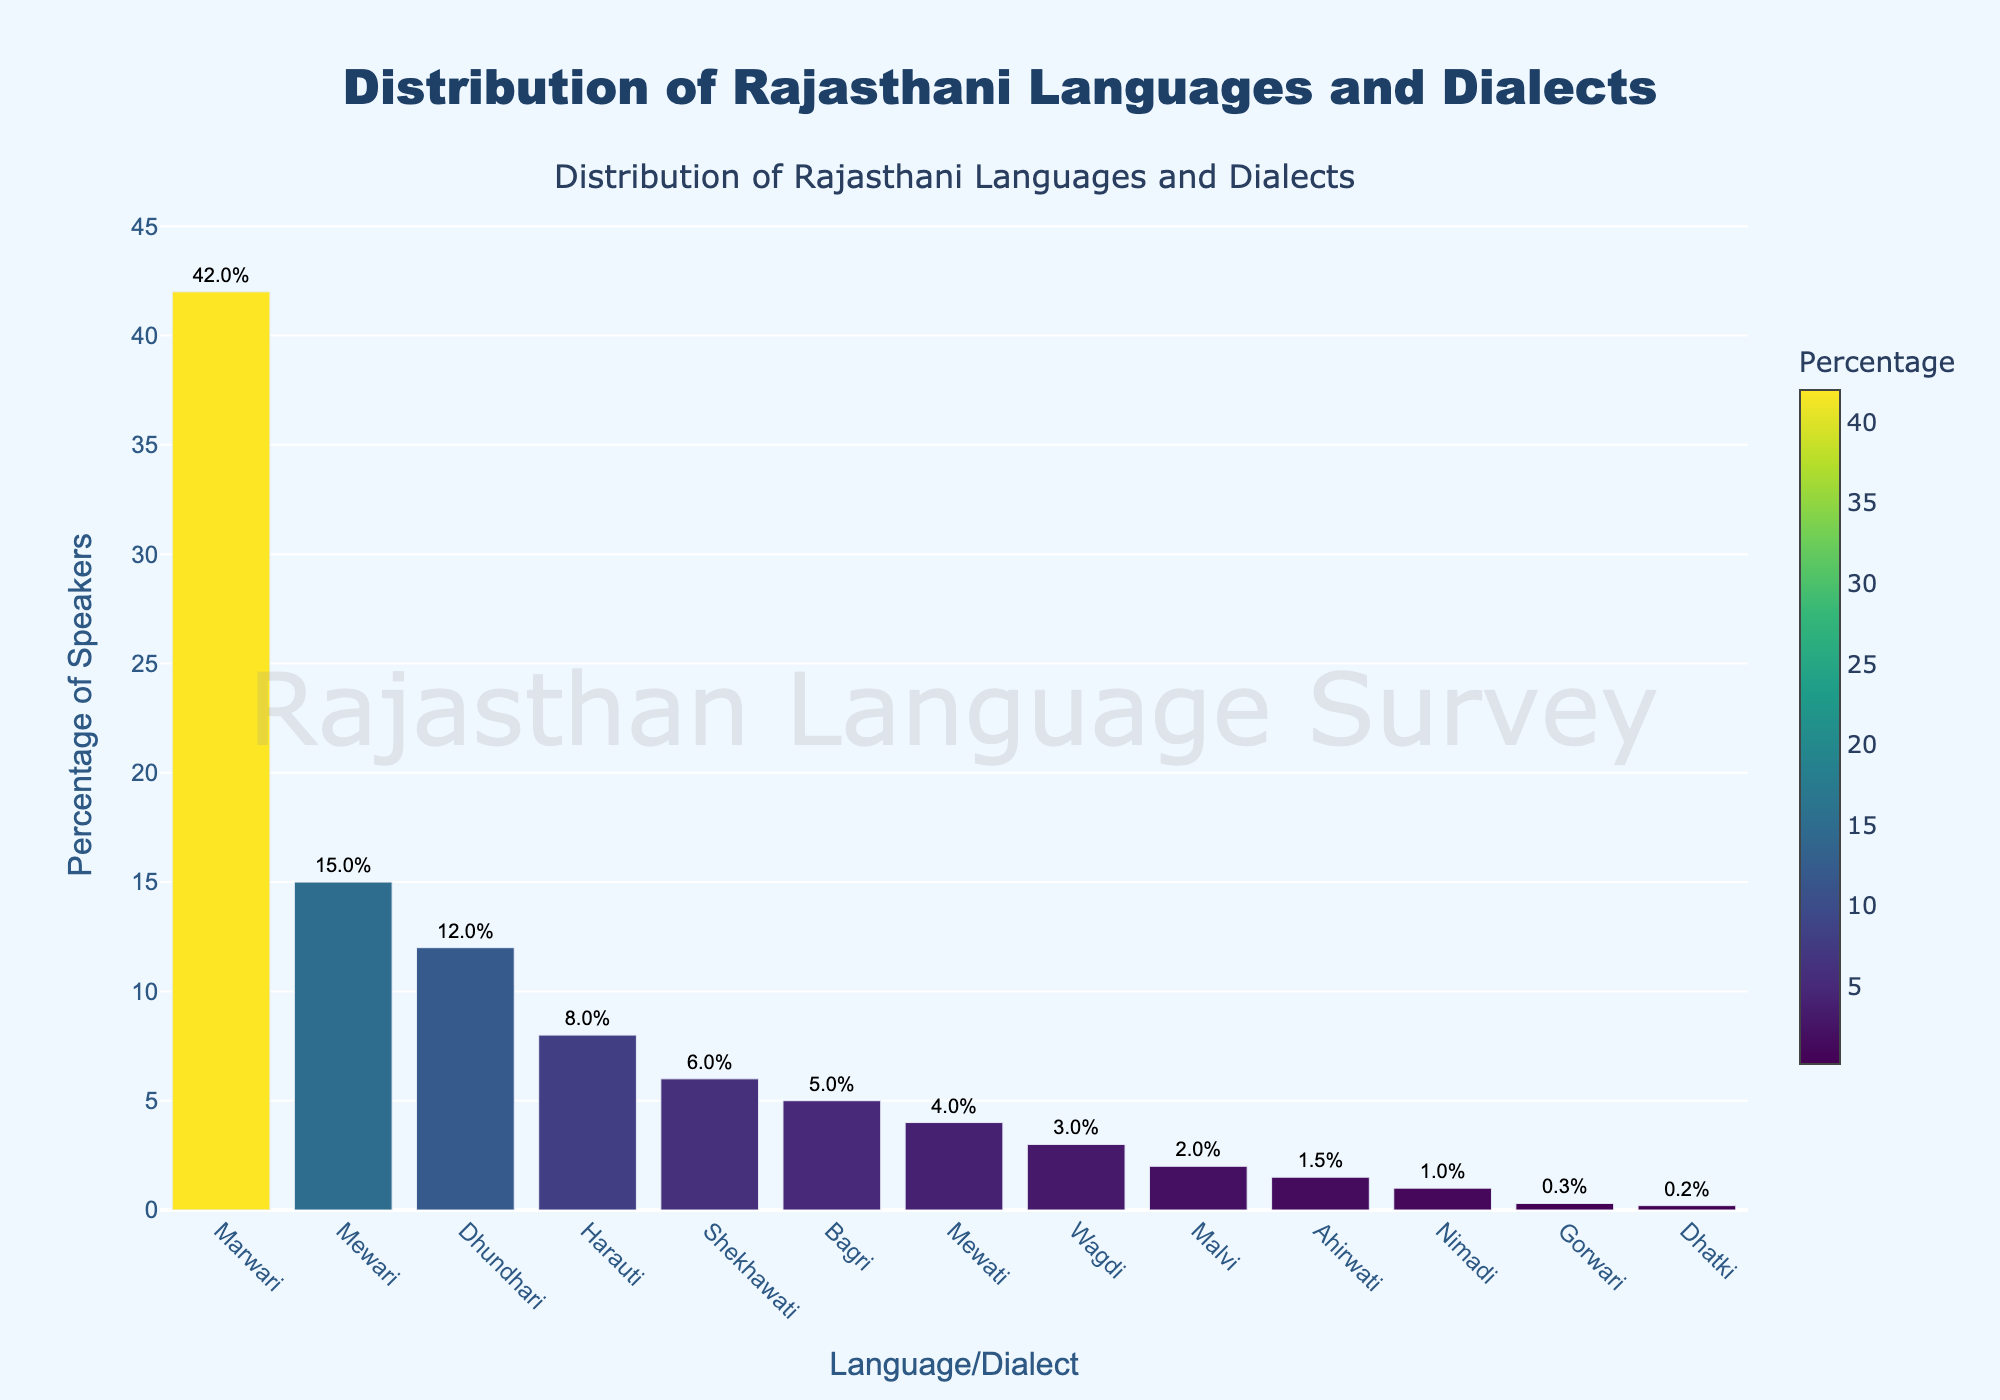What percentage of speakers does the Marwari dialect have? Look at the bar corresponding to the Marwari dialect on the x-axis and note the percentage marked at the top or displayed next to the bar.
Answer: 42% Which dialect has the smallest percentage of speakers, and what is that percentage? Identify the shortest bar on the plot, then read the label on the x-axis and the corresponding percentage.
Answer: Dhatki, 0.2% How much greater is the percentage of Marwari speakers compared to Mewari speakers? Find the percentages for both Marwari and Mewari. Subtract the percentage of Mewari from Marwari (42% - 15%).
Answer: 27% List all the dialects that have more than 10% of speakers. Identify the bars whose percentage values are above 10% and list their corresponding dialects.
Answer: Marwari, Mewari, Dhundhari What is the total percentage of speakers for Shekhawati, Bagri, and Mewati combined? Find the percentages for Shekhawati, Bagri, and Mewati. Add them together (6% + 5% + 4%).
Answer: 15% Which dialect has exactly half the percentage of speakers as Dhundhari? Look at the percentage of Dhundhari (12%) and find a dialect with half of this value (6%).
Answer: Shekhawati What is the percentage difference between Harauti and Dhundhari speakers? Find the percentages for both Harauti and Dhundhari. Subtract the percentage of Harauti from Dhundhari (12% - 8%).
Answer: 4% How many dialects have a percentage of speakers less than 3%? Count the bars where the percentage is less than 3%.
Answer: 4 What percentage of speakers do the three least-spoken dialects have in total? Identify the three smallest bars and sum their percentages (Ahirwati 1.5% + Nimadi 1% + Dhatki 0.2%).
Answer: 2.7% Compare the height and color of the bars corresponding to Marwari and Wagdi. What differences do you observe? Marwari has the tallest bar with a darker color representing a higher percentage, while Wagdi has a shorter bar with a lighter color representing a lower percentage.
Answer: Taller and darker for Marwari, shorter and lighter for Wagdi 